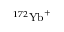Convert formula to latex. <formula><loc_0><loc_0><loc_500><loc_500>^ { 1 7 2 } { Y b } ^ { + }</formula> 